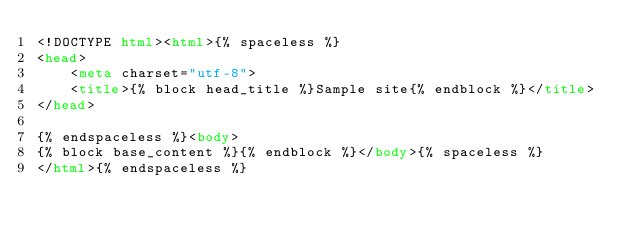Convert code to text. <code><loc_0><loc_0><loc_500><loc_500><_HTML_><!DOCTYPE html><html>{% spaceless %}
<head>
    <meta charset="utf-8">
    <title>{% block head_title %}Sample site{% endblock %}</title>
</head>

{% endspaceless %}<body>
{% block base_content %}{% endblock %}</body>{% spaceless %}
</html>{% endspaceless %}</code> 